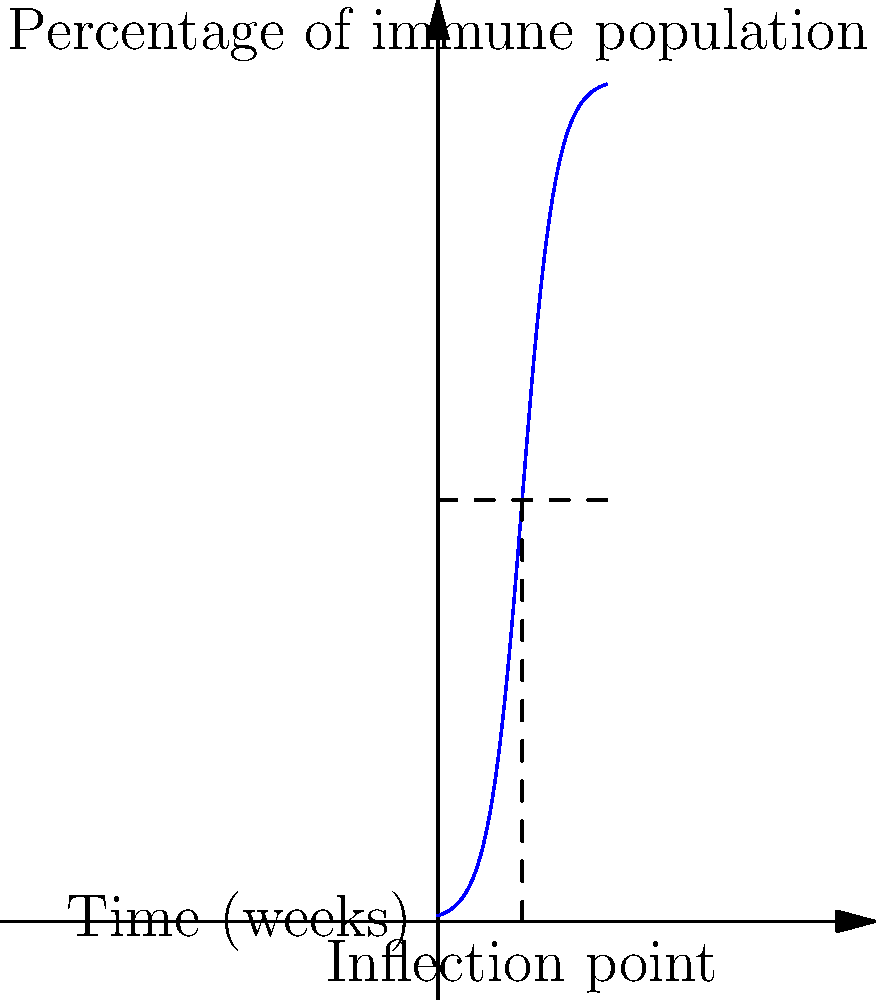In a study on herd immunity development for a novel infectious disease, the percentage of the immune population over time is modeled by the function:

$$ f(t) = \frac{100}{1 + e^{-0.5(t-10)}} $$

where $t$ is time in weeks and $f(t)$ is the percentage of the immune population. Find the inflection point of this S-shaped curve, which represents the time when the rate of immunity development is at its peak. To find the inflection point, we need to follow these steps:

1) The inflection point occurs where the second derivative of the function equals zero.

2) First, let's find the first derivative:
   $$ f'(t) = \frac{100 \cdot 0.5e^{-0.5(t-10)}}{(1 + e^{-0.5(t-10)})^2} = \frac{50e^{-0.5(t-10)}}{(1 + e^{-0.5(t-10)})^2} $$

3) Now, let's find the second derivative:
   $$ f''(t) = \frac{50e^{-0.5(t-10)} \cdot (-0.5)(1 + e^{-0.5(t-10)})^2 - 50e^{-0.5(t-10)} \cdot 2(1 + e^{-0.5(t-10)}) \cdot (-0.5e^{-0.5(t-10)})}{(1 + e^{-0.5(t-10)})^4} $$

4) Simplify:
   $$ f''(t) = \frac{25e^{-0.5(t-10)}(e^{-0.5(t-10)} - 1)}{(1 + e^{-0.5(t-10)})^3} $$

5) Set $f''(t) = 0$ and solve:
   $$ \frac{25e^{-0.5(t-10)}(e^{-0.5(t-10)} - 1)}{(1 + e^{-0.5(t-10)})^3} = 0 $$

   This is true when $e^{-0.5(t-10)} - 1 = 0$, or when $e^{-0.5(t-10)} = 1$

6) Solve for t:
   $-0.5(t-10) = 0$
   $t = 10$

7) Verify: At $t=10$, $f(10) = 50$, which is the midpoint of the S-curve.

Therefore, the inflection point occurs at 10 weeks, when 50% of the population has become immune. This is when the rate of immunity development is at its highest.
Answer: 10 weeks 